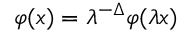<formula> <loc_0><loc_0><loc_500><loc_500>\varphi ( x ) = \lambda ^ { - \Delta } \varphi ( \lambda x )</formula> 